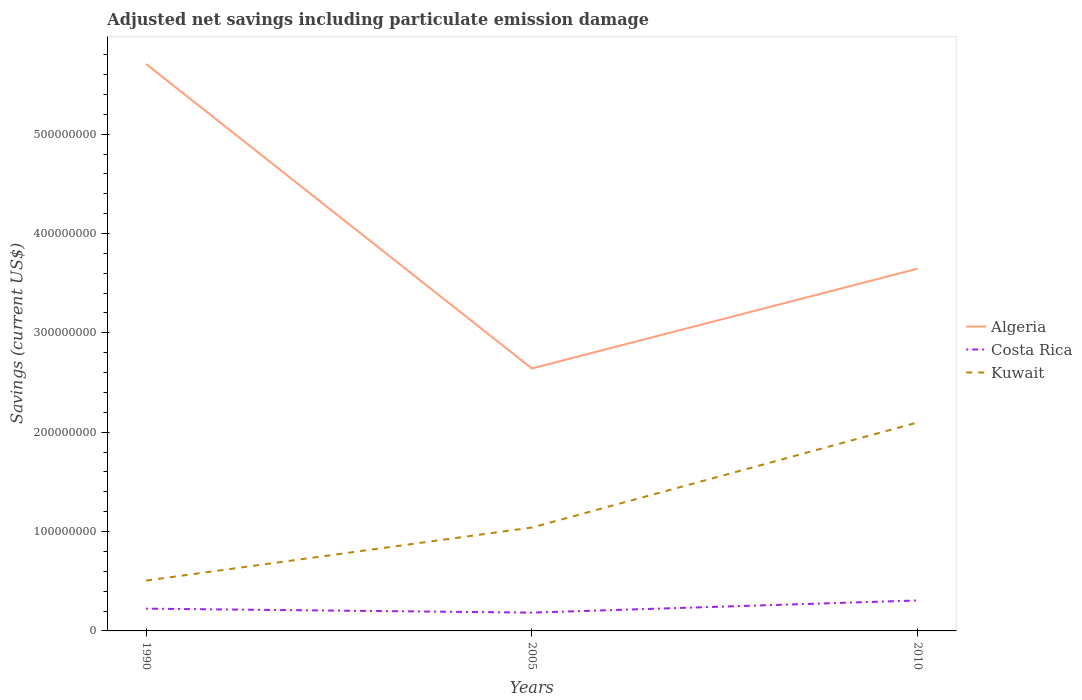How many different coloured lines are there?
Provide a succinct answer. 3. Does the line corresponding to Kuwait intersect with the line corresponding to Algeria?
Make the answer very short. No. Is the number of lines equal to the number of legend labels?
Offer a very short reply. Yes. Across all years, what is the maximum net savings in Costa Rica?
Provide a succinct answer. 1.84e+07. What is the total net savings in Costa Rica in the graph?
Make the answer very short. 3.99e+06. What is the difference between the highest and the second highest net savings in Costa Rica?
Give a very brief answer. 1.22e+07. What is the difference between the highest and the lowest net savings in Algeria?
Offer a terse response. 1. Is the net savings in Algeria strictly greater than the net savings in Kuwait over the years?
Give a very brief answer. No. What is the difference between two consecutive major ticks on the Y-axis?
Provide a short and direct response. 1.00e+08. Are the values on the major ticks of Y-axis written in scientific E-notation?
Ensure brevity in your answer.  No. Does the graph contain grids?
Your answer should be compact. No. How are the legend labels stacked?
Keep it short and to the point. Vertical. What is the title of the graph?
Offer a terse response. Adjusted net savings including particulate emission damage. What is the label or title of the X-axis?
Provide a succinct answer. Years. What is the label or title of the Y-axis?
Provide a succinct answer. Savings (current US$). What is the Savings (current US$) in Algeria in 1990?
Make the answer very short. 5.71e+08. What is the Savings (current US$) in Costa Rica in 1990?
Your answer should be compact. 2.24e+07. What is the Savings (current US$) of Kuwait in 1990?
Your response must be concise. 5.07e+07. What is the Savings (current US$) in Algeria in 2005?
Your answer should be very brief. 2.64e+08. What is the Savings (current US$) of Costa Rica in 2005?
Offer a terse response. 1.84e+07. What is the Savings (current US$) of Kuwait in 2005?
Offer a very short reply. 1.04e+08. What is the Savings (current US$) in Algeria in 2010?
Keep it short and to the point. 3.65e+08. What is the Savings (current US$) in Costa Rica in 2010?
Provide a succinct answer. 3.07e+07. What is the Savings (current US$) in Kuwait in 2010?
Your response must be concise. 2.10e+08. Across all years, what is the maximum Savings (current US$) in Algeria?
Offer a terse response. 5.71e+08. Across all years, what is the maximum Savings (current US$) in Costa Rica?
Your answer should be very brief. 3.07e+07. Across all years, what is the maximum Savings (current US$) of Kuwait?
Make the answer very short. 2.10e+08. Across all years, what is the minimum Savings (current US$) of Algeria?
Provide a short and direct response. 2.64e+08. Across all years, what is the minimum Savings (current US$) in Costa Rica?
Your response must be concise. 1.84e+07. Across all years, what is the minimum Savings (current US$) in Kuwait?
Ensure brevity in your answer.  5.07e+07. What is the total Savings (current US$) in Algeria in the graph?
Provide a succinct answer. 1.20e+09. What is the total Savings (current US$) of Costa Rica in the graph?
Offer a very short reply. 7.15e+07. What is the total Savings (current US$) in Kuwait in the graph?
Your answer should be very brief. 3.65e+08. What is the difference between the Savings (current US$) of Algeria in 1990 and that in 2005?
Make the answer very short. 3.06e+08. What is the difference between the Savings (current US$) of Costa Rica in 1990 and that in 2005?
Provide a succinct answer. 3.99e+06. What is the difference between the Savings (current US$) in Kuwait in 1990 and that in 2005?
Provide a succinct answer. -5.34e+07. What is the difference between the Savings (current US$) of Algeria in 1990 and that in 2010?
Provide a succinct answer. 2.06e+08. What is the difference between the Savings (current US$) of Costa Rica in 1990 and that in 2010?
Offer a terse response. -8.24e+06. What is the difference between the Savings (current US$) in Kuwait in 1990 and that in 2010?
Your answer should be very brief. -1.59e+08. What is the difference between the Savings (current US$) of Algeria in 2005 and that in 2010?
Provide a succinct answer. -1.00e+08. What is the difference between the Savings (current US$) in Costa Rica in 2005 and that in 2010?
Offer a terse response. -1.22e+07. What is the difference between the Savings (current US$) in Kuwait in 2005 and that in 2010?
Keep it short and to the point. -1.06e+08. What is the difference between the Savings (current US$) in Algeria in 1990 and the Savings (current US$) in Costa Rica in 2005?
Ensure brevity in your answer.  5.52e+08. What is the difference between the Savings (current US$) in Algeria in 1990 and the Savings (current US$) in Kuwait in 2005?
Your response must be concise. 4.67e+08. What is the difference between the Savings (current US$) in Costa Rica in 1990 and the Savings (current US$) in Kuwait in 2005?
Provide a short and direct response. -8.16e+07. What is the difference between the Savings (current US$) of Algeria in 1990 and the Savings (current US$) of Costa Rica in 2010?
Give a very brief answer. 5.40e+08. What is the difference between the Savings (current US$) of Algeria in 1990 and the Savings (current US$) of Kuwait in 2010?
Provide a short and direct response. 3.61e+08. What is the difference between the Savings (current US$) in Costa Rica in 1990 and the Savings (current US$) in Kuwait in 2010?
Offer a very short reply. -1.87e+08. What is the difference between the Savings (current US$) in Algeria in 2005 and the Savings (current US$) in Costa Rica in 2010?
Your answer should be compact. 2.34e+08. What is the difference between the Savings (current US$) in Algeria in 2005 and the Savings (current US$) in Kuwait in 2010?
Ensure brevity in your answer.  5.43e+07. What is the difference between the Savings (current US$) in Costa Rica in 2005 and the Savings (current US$) in Kuwait in 2010?
Make the answer very short. -1.91e+08. What is the average Savings (current US$) of Algeria per year?
Make the answer very short. 4.00e+08. What is the average Savings (current US$) of Costa Rica per year?
Provide a succinct answer. 2.38e+07. What is the average Savings (current US$) in Kuwait per year?
Offer a terse response. 1.22e+08. In the year 1990, what is the difference between the Savings (current US$) of Algeria and Savings (current US$) of Costa Rica?
Keep it short and to the point. 5.48e+08. In the year 1990, what is the difference between the Savings (current US$) in Algeria and Savings (current US$) in Kuwait?
Your answer should be very brief. 5.20e+08. In the year 1990, what is the difference between the Savings (current US$) in Costa Rica and Savings (current US$) in Kuwait?
Give a very brief answer. -2.83e+07. In the year 2005, what is the difference between the Savings (current US$) of Algeria and Savings (current US$) of Costa Rica?
Provide a short and direct response. 2.46e+08. In the year 2005, what is the difference between the Savings (current US$) of Algeria and Savings (current US$) of Kuwait?
Offer a very short reply. 1.60e+08. In the year 2005, what is the difference between the Savings (current US$) of Costa Rica and Savings (current US$) of Kuwait?
Your answer should be compact. -8.56e+07. In the year 2010, what is the difference between the Savings (current US$) in Algeria and Savings (current US$) in Costa Rica?
Offer a terse response. 3.34e+08. In the year 2010, what is the difference between the Savings (current US$) of Algeria and Savings (current US$) of Kuwait?
Your response must be concise. 1.55e+08. In the year 2010, what is the difference between the Savings (current US$) in Costa Rica and Savings (current US$) in Kuwait?
Ensure brevity in your answer.  -1.79e+08. What is the ratio of the Savings (current US$) in Algeria in 1990 to that in 2005?
Your answer should be very brief. 2.16. What is the ratio of the Savings (current US$) in Costa Rica in 1990 to that in 2005?
Keep it short and to the point. 1.22. What is the ratio of the Savings (current US$) in Kuwait in 1990 to that in 2005?
Make the answer very short. 0.49. What is the ratio of the Savings (current US$) in Algeria in 1990 to that in 2010?
Your answer should be compact. 1.56. What is the ratio of the Savings (current US$) of Costa Rica in 1990 to that in 2010?
Ensure brevity in your answer.  0.73. What is the ratio of the Savings (current US$) of Kuwait in 1990 to that in 2010?
Give a very brief answer. 0.24. What is the ratio of the Savings (current US$) of Algeria in 2005 to that in 2010?
Offer a very short reply. 0.72. What is the ratio of the Savings (current US$) of Costa Rica in 2005 to that in 2010?
Keep it short and to the point. 0.6. What is the ratio of the Savings (current US$) in Kuwait in 2005 to that in 2010?
Give a very brief answer. 0.5. What is the difference between the highest and the second highest Savings (current US$) in Algeria?
Your answer should be very brief. 2.06e+08. What is the difference between the highest and the second highest Savings (current US$) in Costa Rica?
Keep it short and to the point. 8.24e+06. What is the difference between the highest and the second highest Savings (current US$) in Kuwait?
Give a very brief answer. 1.06e+08. What is the difference between the highest and the lowest Savings (current US$) in Algeria?
Ensure brevity in your answer.  3.06e+08. What is the difference between the highest and the lowest Savings (current US$) of Costa Rica?
Your answer should be very brief. 1.22e+07. What is the difference between the highest and the lowest Savings (current US$) in Kuwait?
Keep it short and to the point. 1.59e+08. 